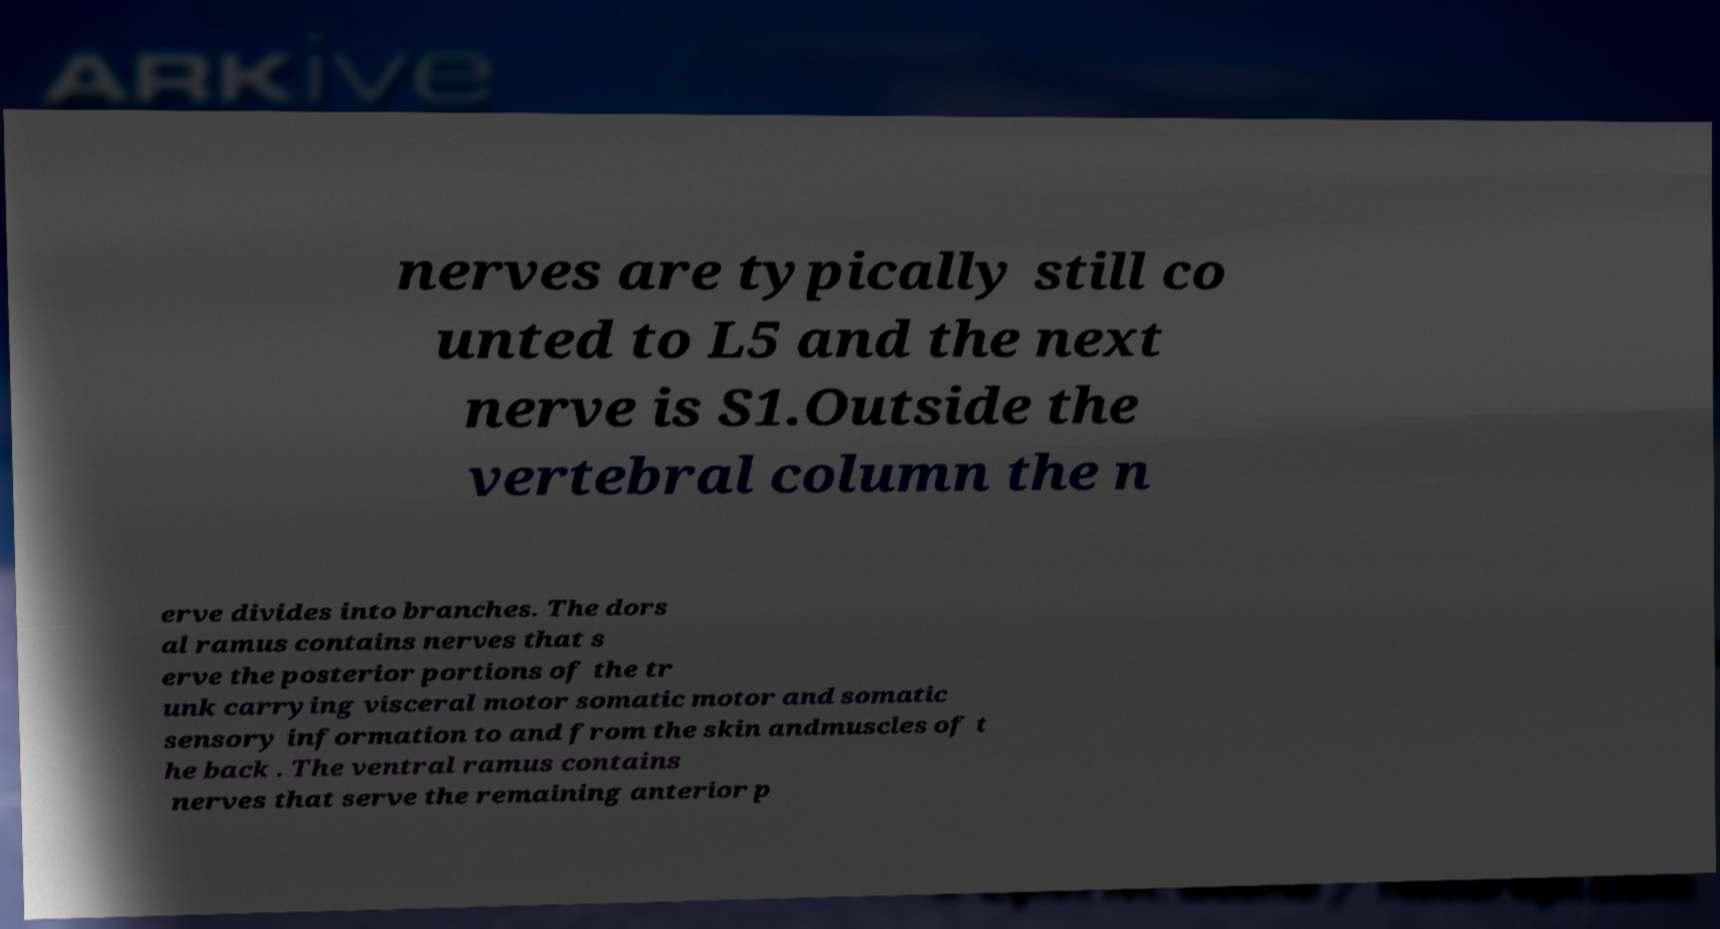I need the written content from this picture converted into text. Can you do that? nerves are typically still co unted to L5 and the next nerve is S1.Outside the vertebral column the n erve divides into branches. The dors al ramus contains nerves that s erve the posterior portions of the tr unk carrying visceral motor somatic motor and somatic sensory information to and from the skin andmuscles of t he back . The ventral ramus contains nerves that serve the remaining anterior p 